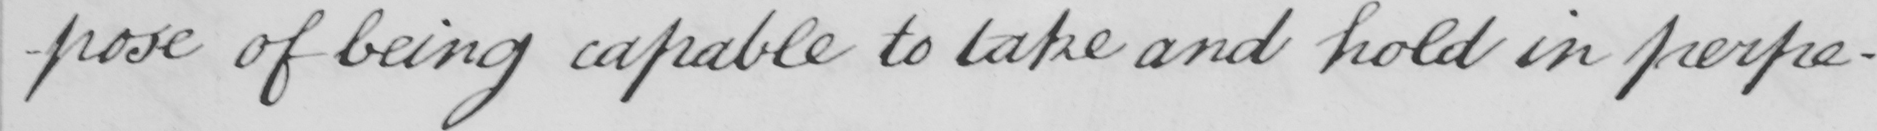Transcribe the text shown in this historical manuscript line. -pose of being capable to take and hold in perpe- 